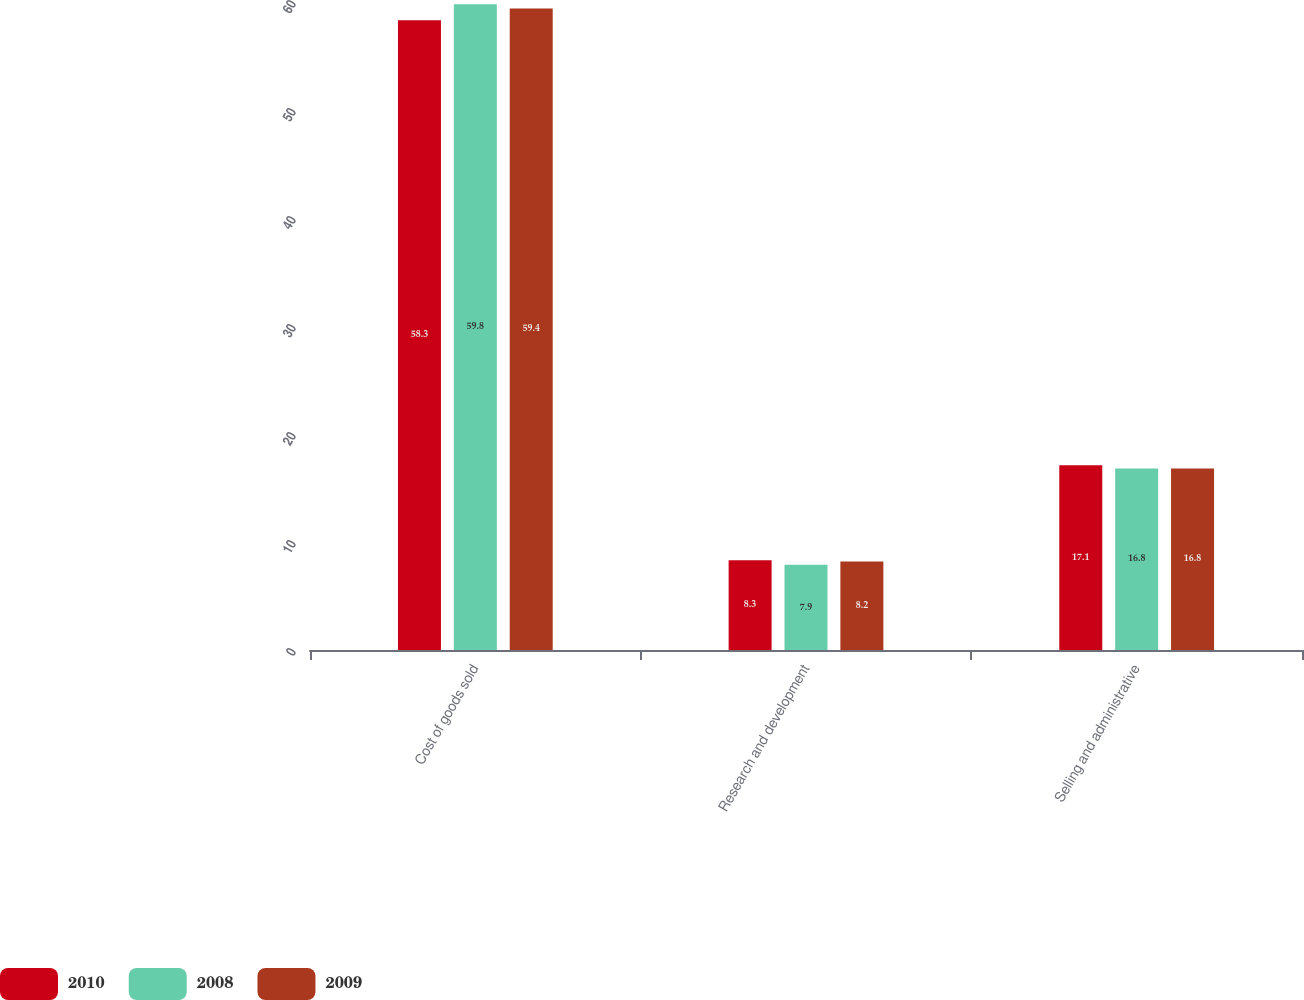Convert chart to OTSL. <chart><loc_0><loc_0><loc_500><loc_500><stacked_bar_chart><ecel><fcel>Cost of goods sold<fcel>Research and development<fcel>Selling and administrative<nl><fcel>2010<fcel>58.3<fcel>8.3<fcel>17.1<nl><fcel>2008<fcel>59.8<fcel>7.9<fcel>16.8<nl><fcel>2009<fcel>59.4<fcel>8.2<fcel>16.8<nl></chart> 